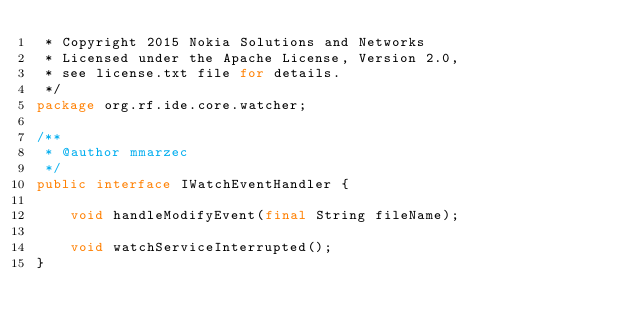Convert code to text. <code><loc_0><loc_0><loc_500><loc_500><_Java_> * Copyright 2015 Nokia Solutions and Networks
 * Licensed under the Apache License, Version 2.0,
 * see license.txt file for details.
 */
package org.rf.ide.core.watcher;

/**
 * @author mmarzec
 */
public interface IWatchEventHandler {

    void handleModifyEvent(final String fileName);

    void watchServiceInterrupted();
}
</code> 